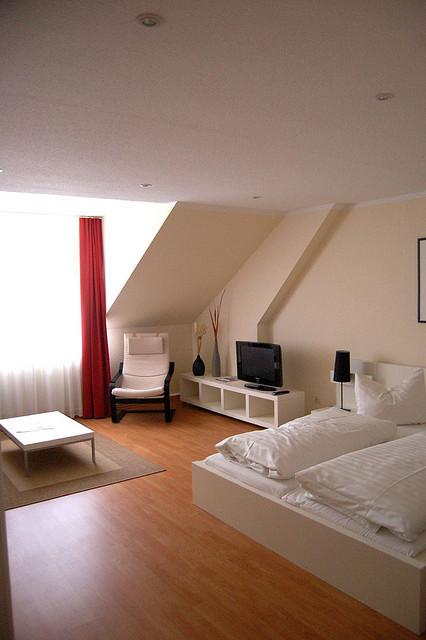How many watts does a night lamp use?

Choices:
A) 3-7.5
B) 5-10
C) 1-2
D) 2.5-3.5 3-7.5 